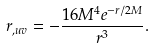<formula> <loc_0><loc_0><loc_500><loc_500>r _ { , u v } = - \frac { 1 6 M ^ { 4 } e ^ { - r / 2 M } } { r ^ { 3 } } .</formula> 